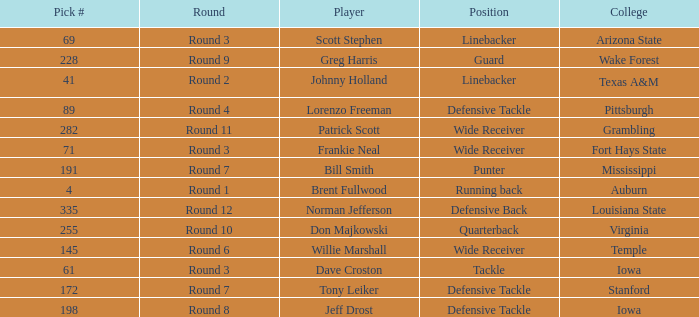Which round goes to Stanford college? Round 7. 